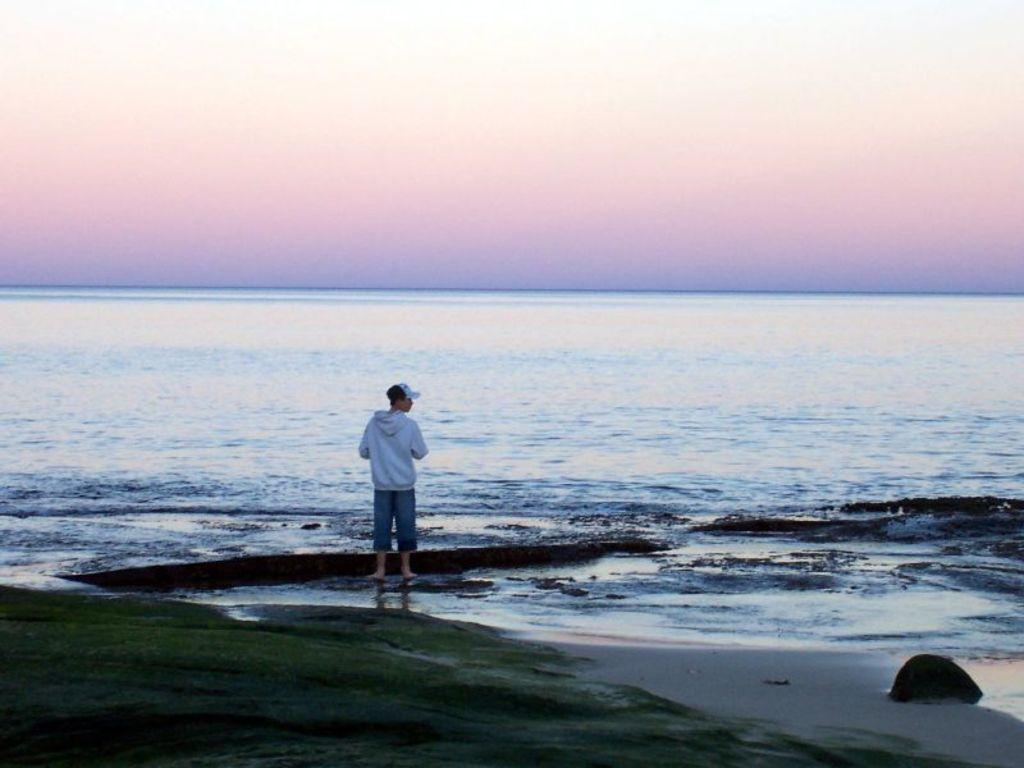What is the main subject of the image? There is a man in the image. What is the man doing in the image? The man is standing in the image. Where is the man located in the image? The man is in front of the sea in the image. What type of calculator can be seen in the man's hand in the image? There is no calculator present in the image; the man is not holding anything in his hand. 